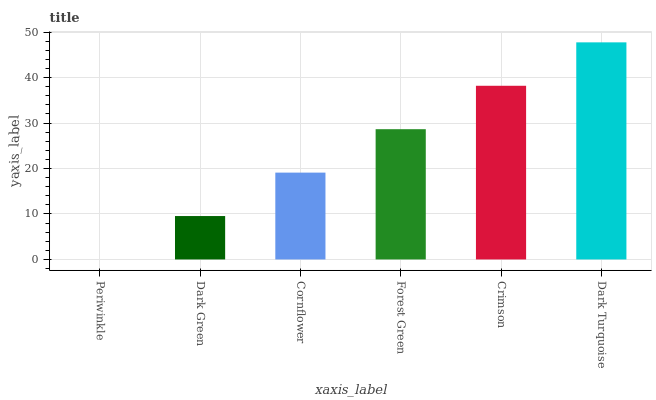Is Periwinkle the minimum?
Answer yes or no. Yes. Is Dark Turquoise the maximum?
Answer yes or no. Yes. Is Dark Green the minimum?
Answer yes or no. No. Is Dark Green the maximum?
Answer yes or no. No. Is Dark Green greater than Periwinkle?
Answer yes or no. Yes. Is Periwinkle less than Dark Green?
Answer yes or no. Yes. Is Periwinkle greater than Dark Green?
Answer yes or no. No. Is Dark Green less than Periwinkle?
Answer yes or no. No. Is Forest Green the high median?
Answer yes or no. Yes. Is Cornflower the low median?
Answer yes or no. Yes. Is Crimson the high median?
Answer yes or no. No. Is Crimson the low median?
Answer yes or no. No. 